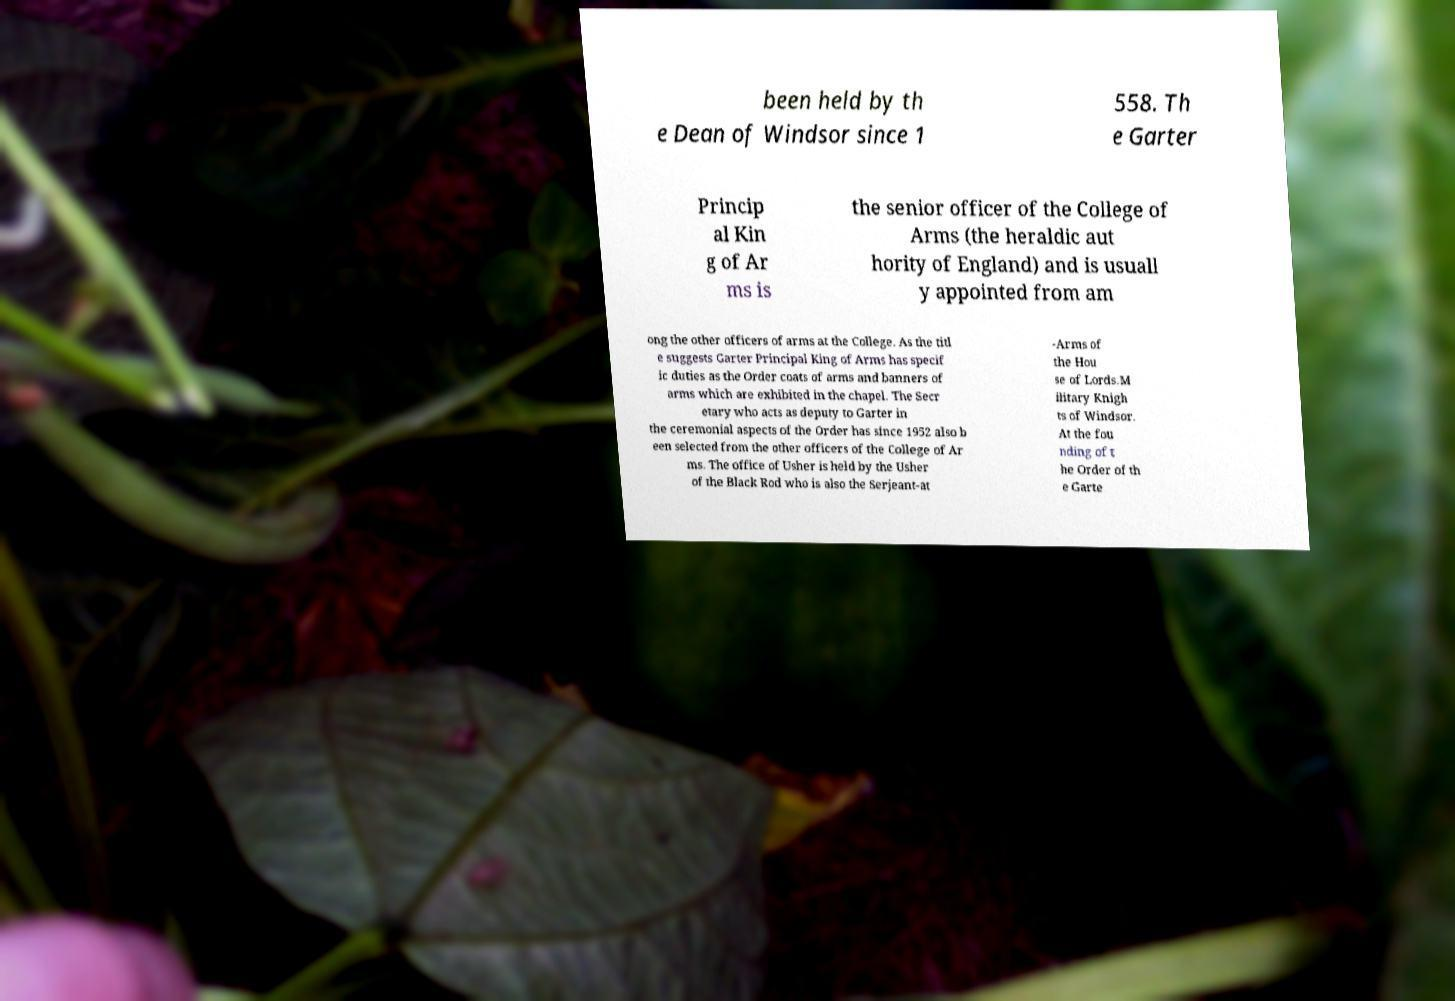What messages or text are displayed in this image? I need them in a readable, typed format. been held by th e Dean of Windsor since 1 558. Th e Garter Princip al Kin g of Ar ms is the senior officer of the College of Arms (the heraldic aut hority of England) and is usuall y appointed from am ong the other officers of arms at the College. As the titl e suggests Garter Principal King of Arms has specif ic duties as the Order coats of arms and banners of arms which are exhibited in the chapel. The Secr etary who acts as deputy to Garter in the ceremonial aspects of the Order has since 1952 also b een selected from the other officers of the College of Ar ms. The office of Usher is held by the Usher of the Black Rod who is also the Serjeant-at -Arms of the Hou se of Lords.M ilitary Knigh ts of Windsor. At the fou nding of t he Order of th e Garte 